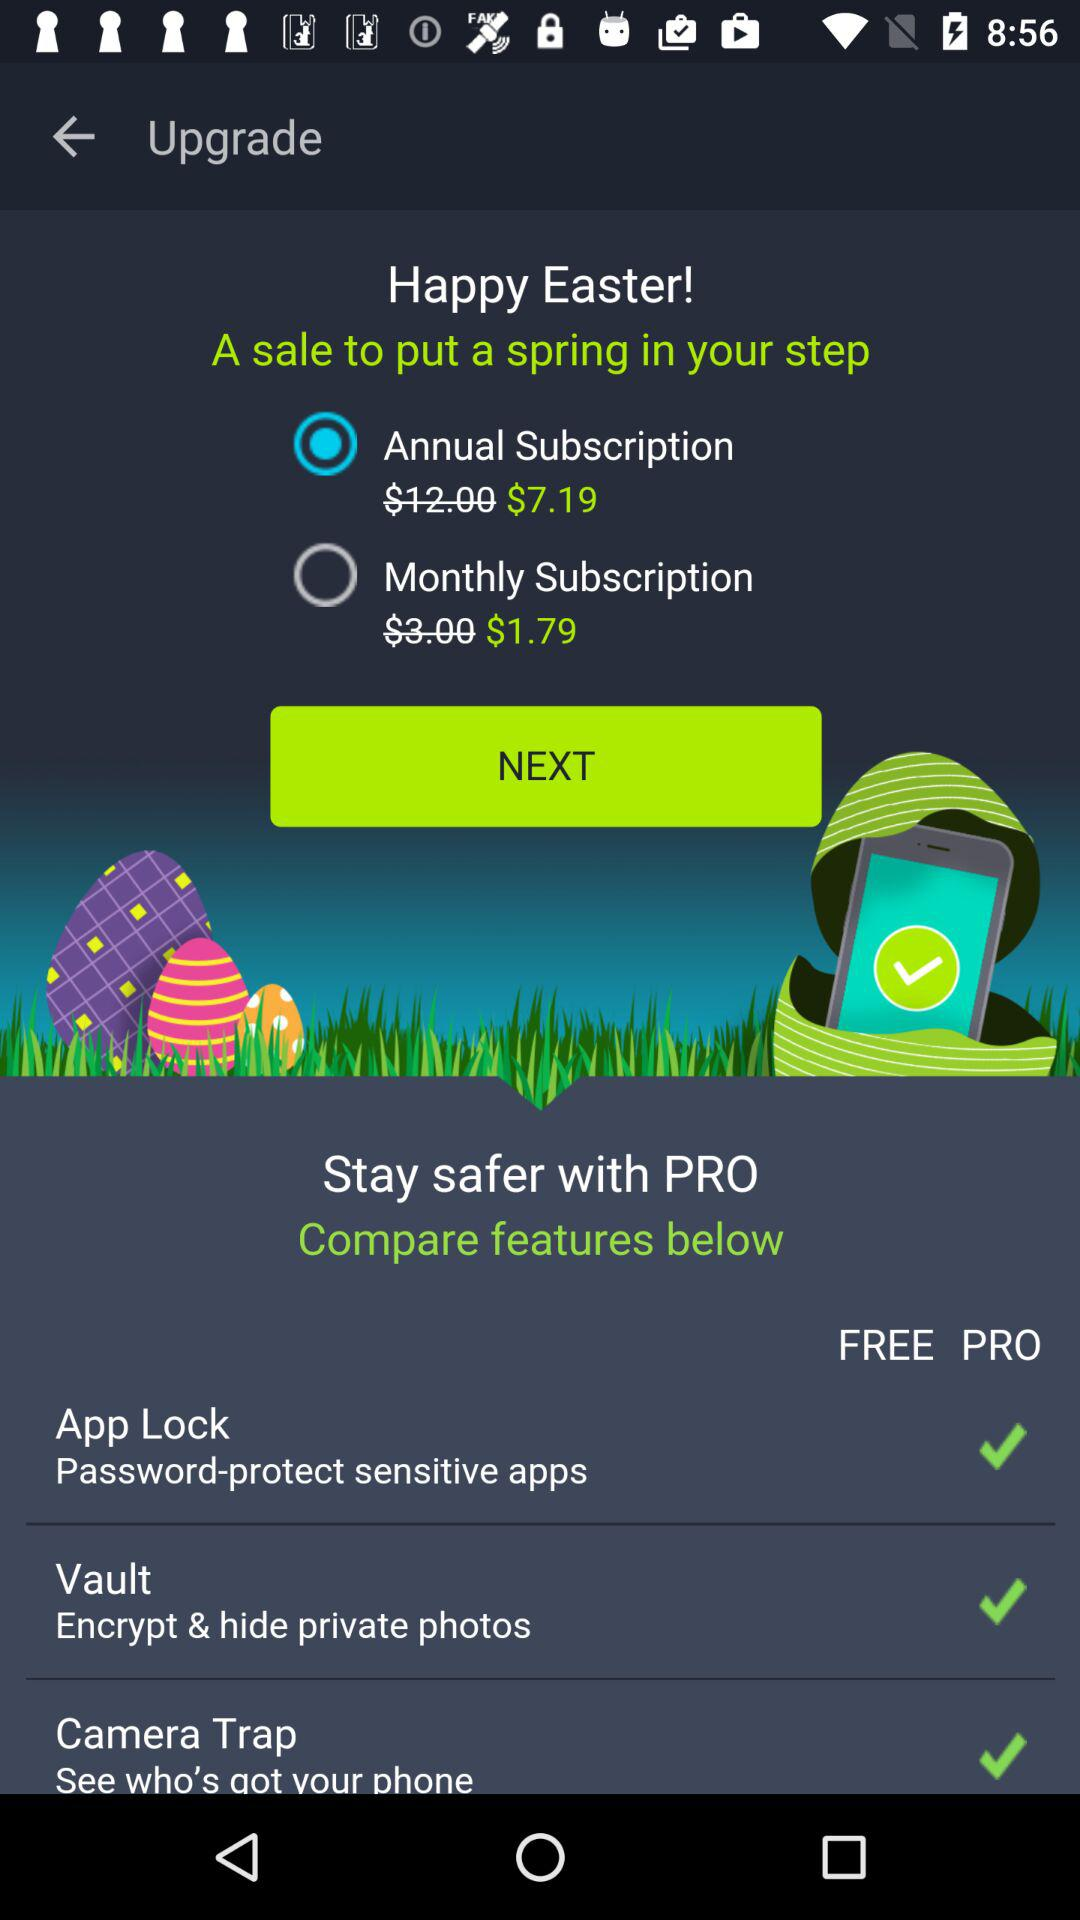What is the cost of the annual subscription? The cost of the annual subscription is $7.19. 